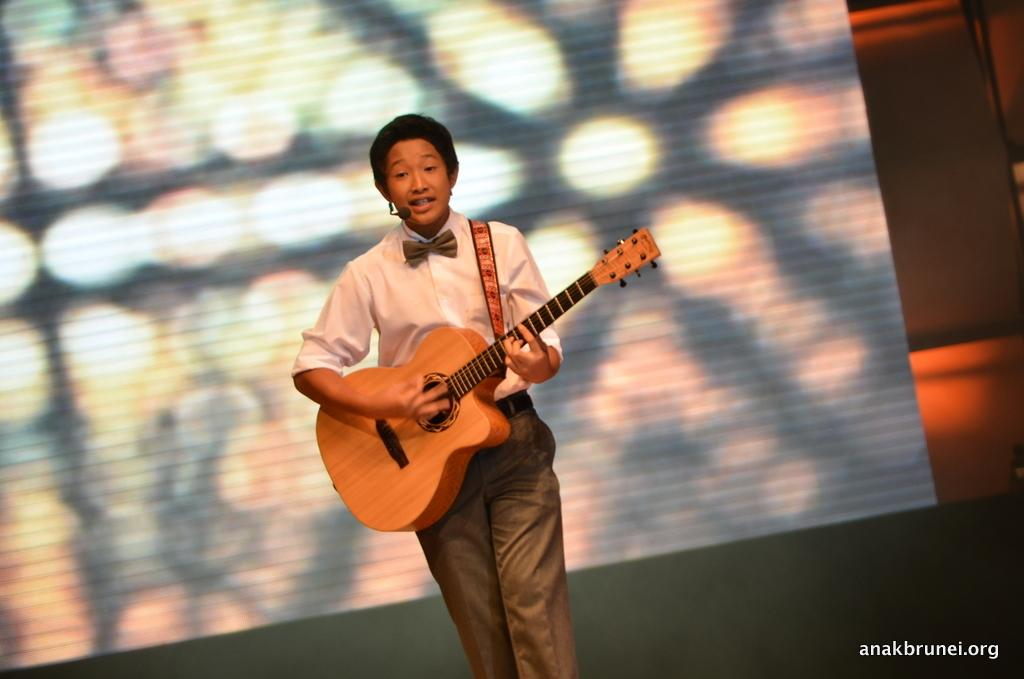What is the main subject of the image? There is a person in the image. What is the person wearing? The person is wearing a white dress. What activity is the person engaged in? The person is playing a guitar. What type of medical advice is the person giving in the image? There is no indication in the image that the person is giving medical advice or acting as a doctor. 